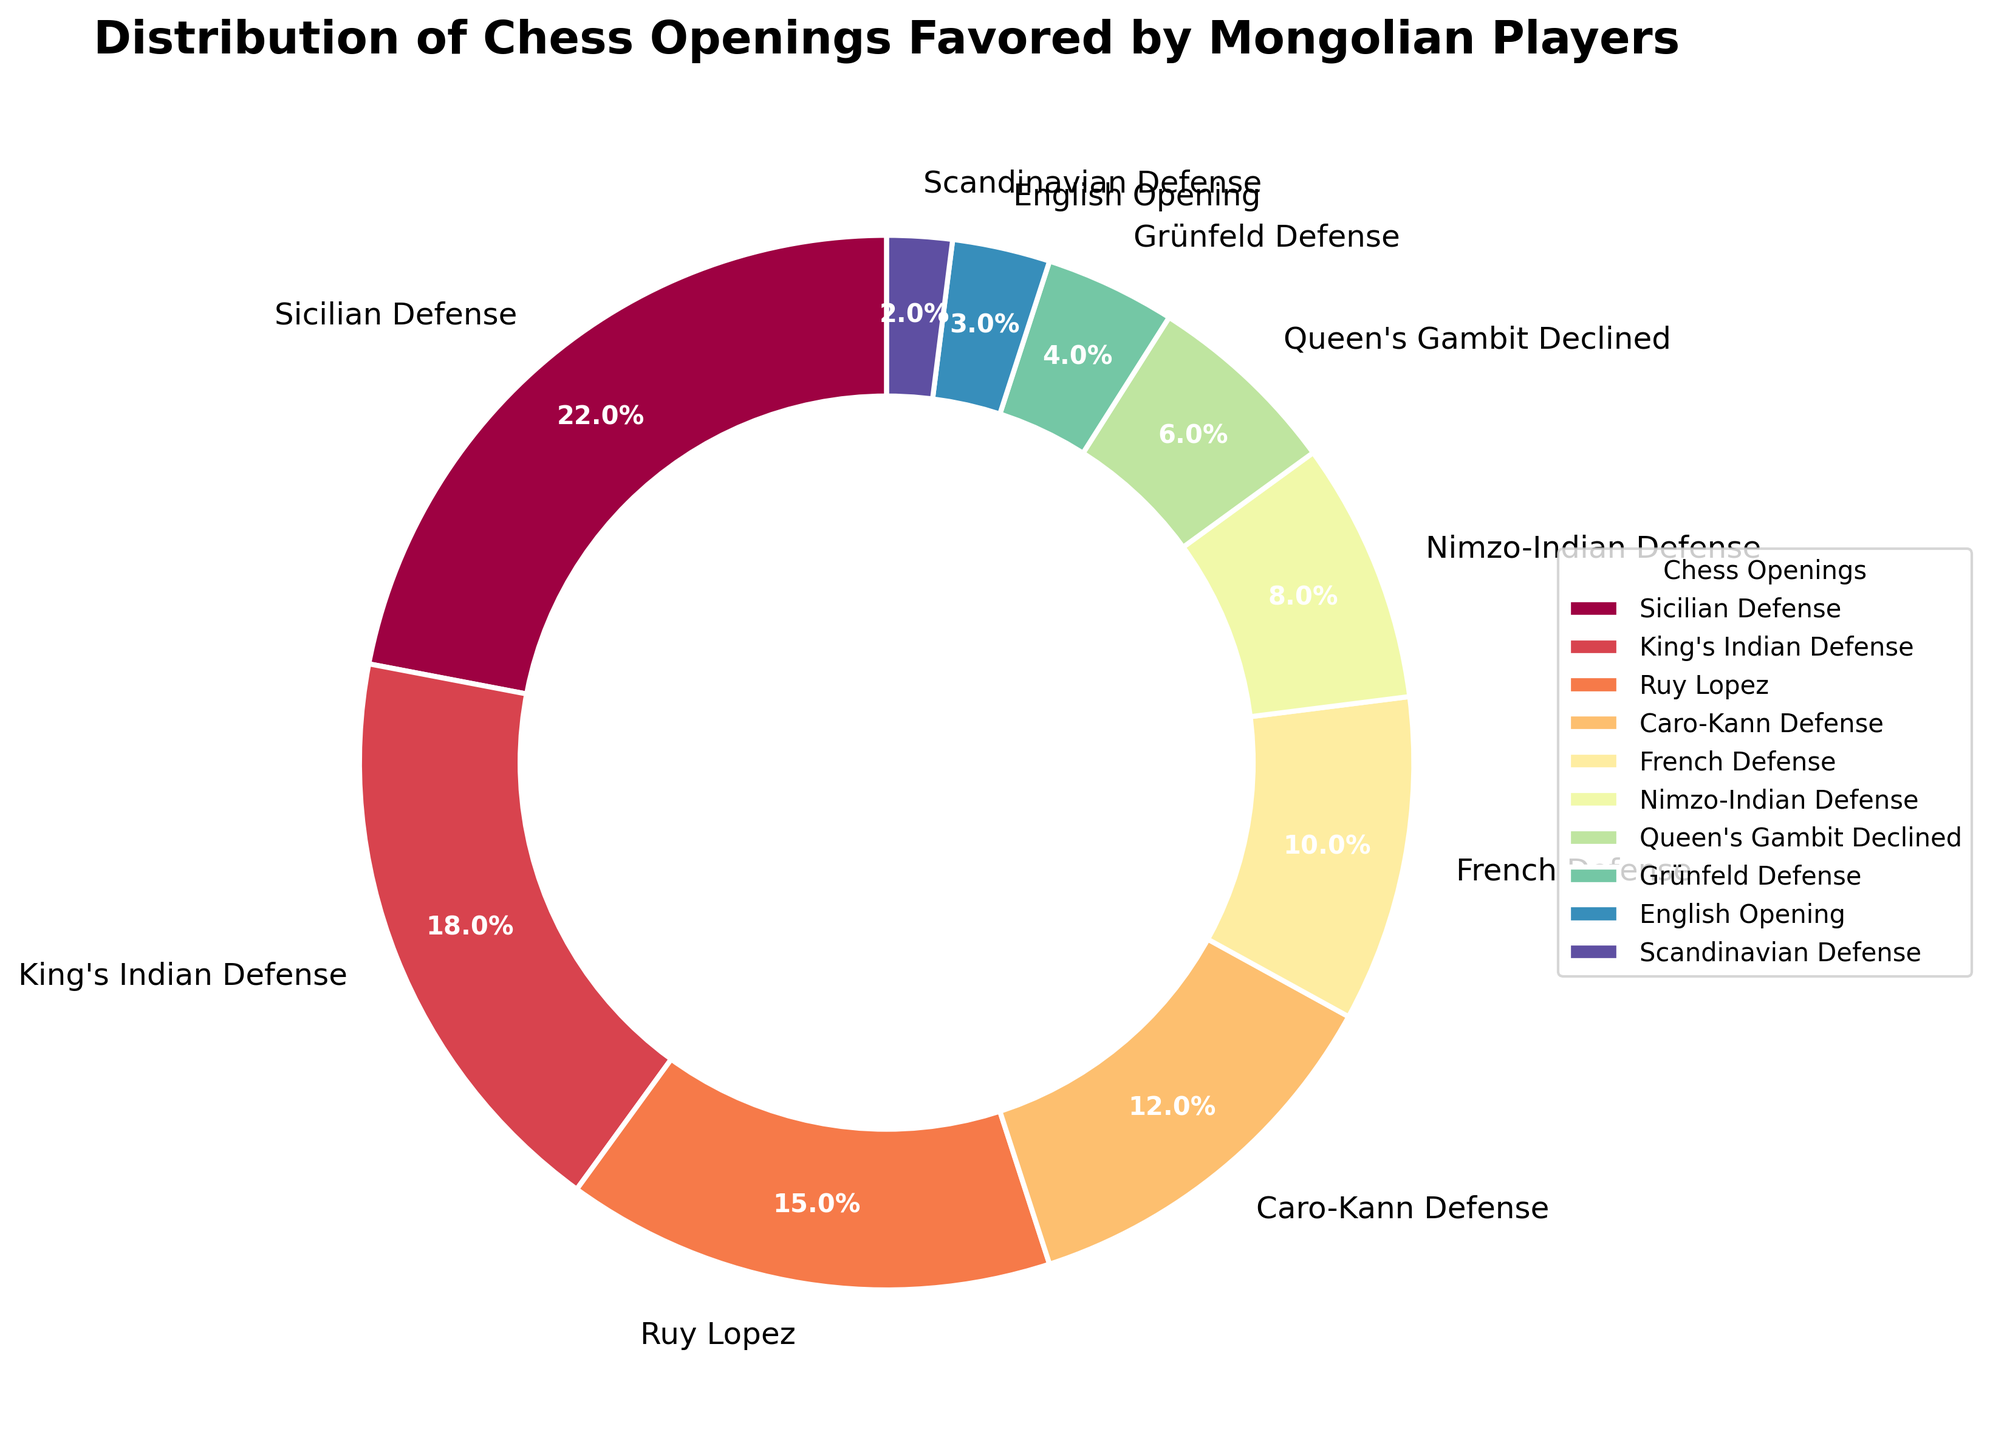What's the most favored chess opening by Mongolian players? The largest wedge in the pie chart represents the most favored opening. The Sicilian Defense section is the largest.
Answer: Sicilian Defense Which three openings are least favored by Mongolian players? The smallest wedges in the pie chart represent the least favored openings. The Scandinavian Defense, English Opening, and Grünfeld Defense wedges are the smallest.
Answer: Scandinavian Defense, English Opening, Grünfeld Defense How much more popular is the most favored opening compared to the least favored opening? Subtract the percentage of the least favored opening from the percentage of the most favored opening. Sicilian Defense (22%) - Scandinavian Defense (2%) = 20%.
Answer: 20% Combine the percentages of openings with "King" in their name. What do you get? Add the percentages of King's Indian Defense and King's Gambit Declined. King's Indian Defense (18%) + King's Gambit Declined (6%) = 24%.
Answer: 24% Which opening has nearly the same level of preference as the Ruy Lopez? Find openings with percentages close to that of Ruy Lopez (15%). The Caro-Kann Defense has 12%, which is relatively close.
Answer: Caro-Kann Defense Rank the top three chess openings favored by Mongolian players. Arrange the percentages in descending order and list the top three. Sicilian Defense (22%), King's Indian Defense (18%), Ruy Lopez (15%).
Answer: Sicilian Defense, King's Indian Defense, Ruy Lopez What fraction of players prefer either French Defense or Caro-Kann Defense? Add the percentages of French Defense and Caro-Kann Defense and convert to a fraction. French Defense (10%) + Caro-Kann Defense (12%) = 22%, which is 22/100 or 11/50.
Answer: 11/50 What’s the combined preference percentage of routes originating from the "Indian" family of openings? Add the percentages of King's Indian Defense, Nimzo-Indian Defense and Grünfeld Defense. King's Indian Defense (18%) + Nimzo-Indian Defense (8%) + Grünfeld Defense (4%) = 30%.
Answer: 30% Which opening is favored by more players: Queen's Gambit Declined or French Defense? Compare the percentages of Queen's Gambit Declined and French Defense. French Defense (10%) is higher than Queen's Gambit Declined (6%).
Answer: French Defense 